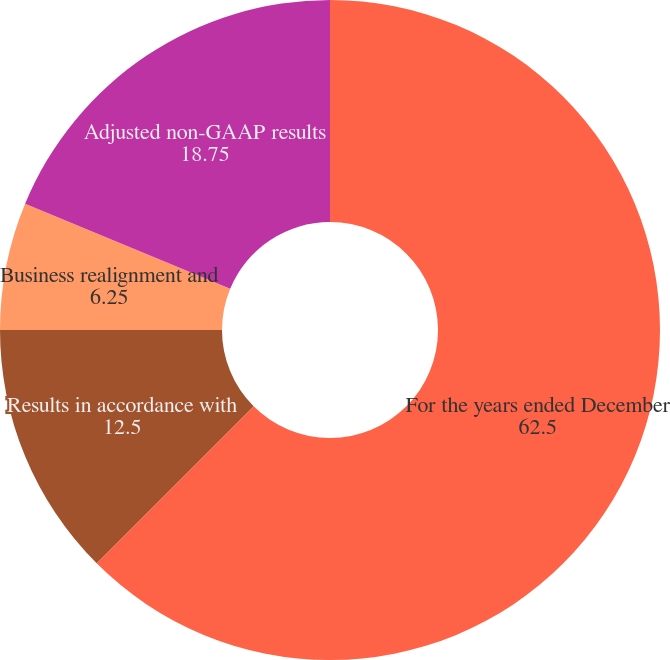Convert chart to OTSL. <chart><loc_0><loc_0><loc_500><loc_500><pie_chart><fcel>For the years ended December<fcel>Results in accordance with<fcel>Business realignment charges<fcel>Business realignment and<fcel>Adjusted non-GAAP results<nl><fcel>62.5%<fcel>12.5%<fcel>0.0%<fcel>6.25%<fcel>18.75%<nl></chart> 